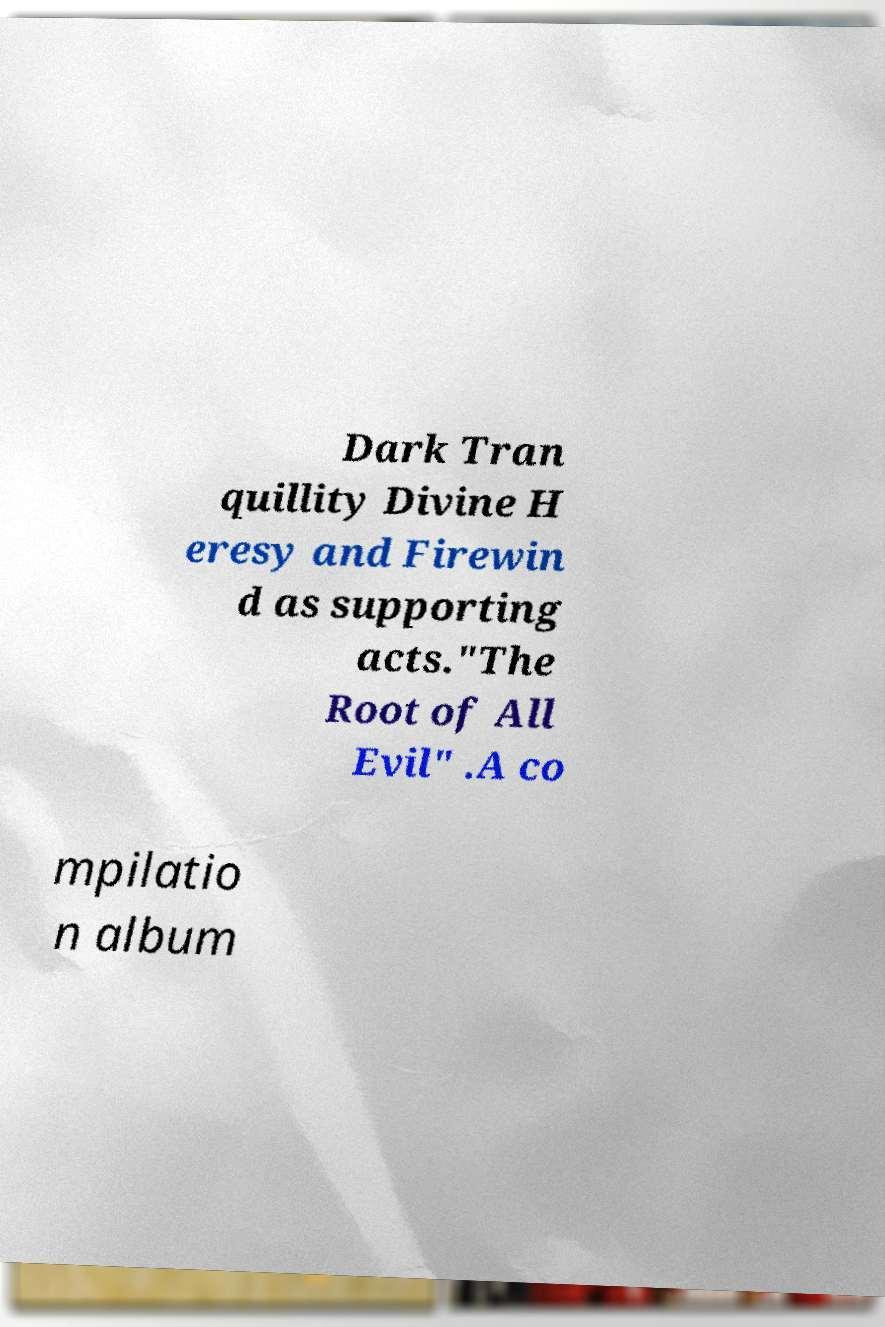Can you accurately transcribe the text from the provided image for me? Dark Tran quillity Divine H eresy and Firewin d as supporting acts."The Root of All Evil" .A co mpilatio n album 